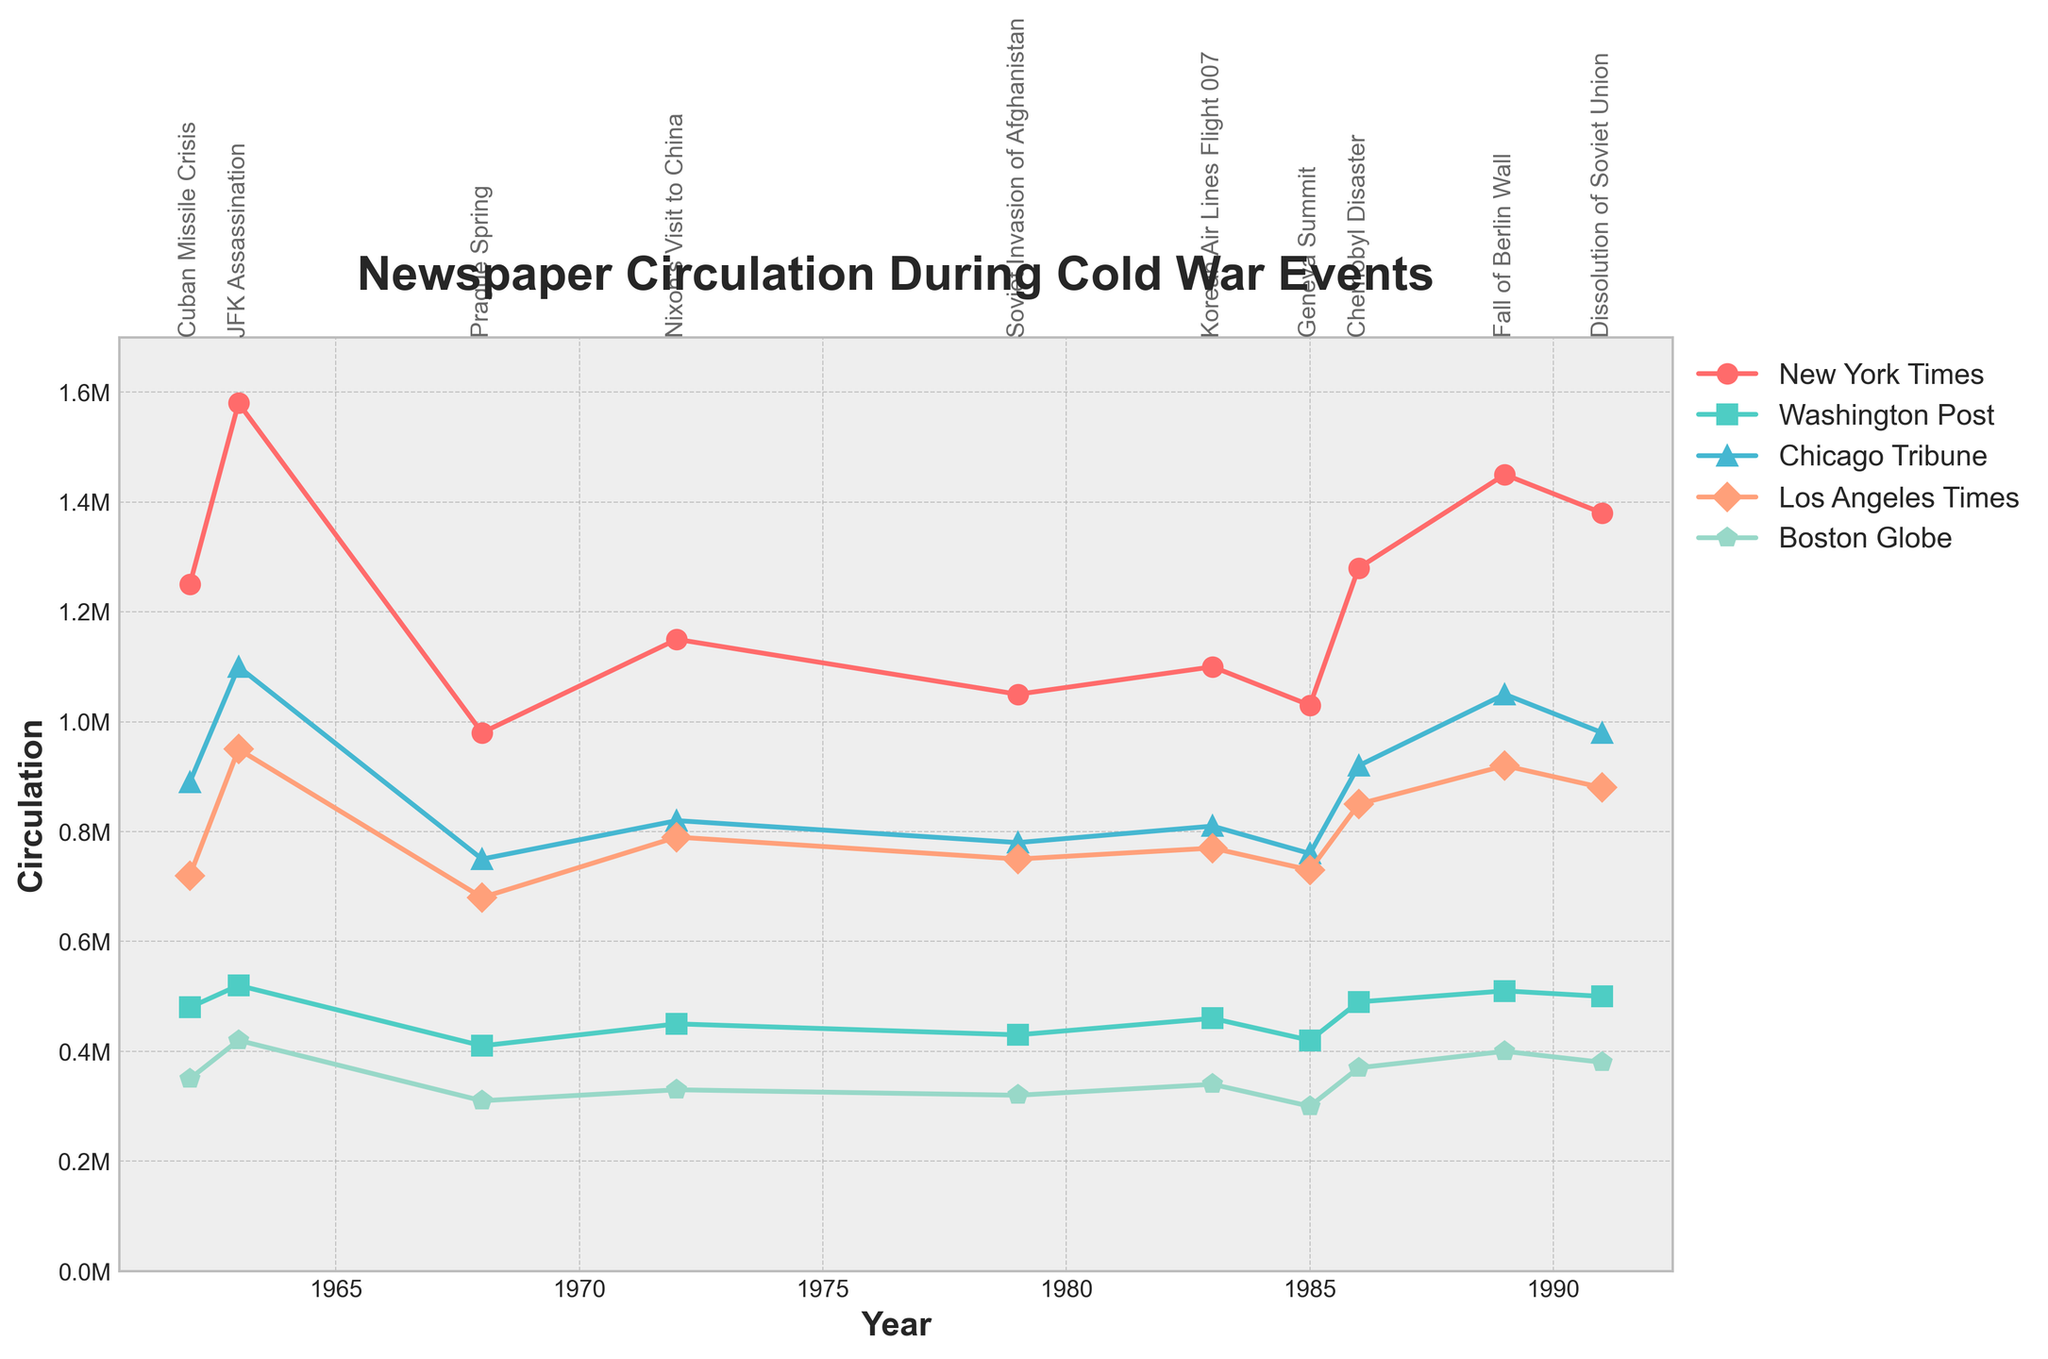Which newspaper saw the highest peak in circulation during the JFK Assassination? To find the highest peak during the JFK Assassination, observe the data point for 1963. The New York Times had the highest circulation with 1,580,000.
Answer: New York Times What event led to the lowest circulation for newspapers like the Washington Post and Boston Globe? Look at the data points for each year and identify the lowest values. For the Washington Post and Boston Globe, the Prague Spring in 1968 had the lowest circulations of 410,000 and 310,000 respectively.
Answer: Prague Spring How did the circulation of the Los Angeles Times change from the Cuban Missile Crisis to the Fall of Berlin Wall? Note the values for the Los Angeles Times in 1962 and 1989. The values increased from 720,000 to 920,000, which is a change of +200,000.
Answer: Increased by 200,000 Which event saw a higher circulation increase, the New York Times during the Chernobyl Disaster or the Chicago Tribune during the Fall of Berlin Wall compared to the previous event? For the New York Times, the increase from the previous event in 1985 (Geneva Summit) to 1986 (Chernobyl Disaster) was 1280000 - 1030000 = 250000. For the Chicago Tribune, the increase from 1986 (Chernobyl Disaster) to 1989 (Fall of Berlin Wall) was 1050000 - 920000 = 130000. The New York Times saw a higher increase.
Answer: Chernobyl Disaster (New York Times) Compare the trends in circulation for the Washington Post and Chicago Tribune between 1985 and 1991, and determine which newspaper had a more stable circulation. Examine the circulations for the listed years. The values for the Washington Post fluctuate between 420,000 and 500,000, whereas the Chicago Tribune's values range from 760,000 to 980,000. The smaller range (80,000 vs 220,000) indicates the Washington Post had a more stable circulation.
Answer: Washington Post Which newspaper had the smallest relative circulation change during the Soviet Invasion of Afghanistan (1979) compared to Nixon's Visit to China (1972)? For each newspaper, calculate the relative change as (value in 1979 - value in 1972) / value in 1972. New York Times: (1050000 - 1150000) / 1150000 = -0.087; Washington Post: (430000 - 450000) / 450000 = -0.044; Chicago Tribune: (780000 - 820000) / 820000 = -0.049; Los Angeles Times: (750000 - 790000) / 790000 = -0.051; Boston Globe: (320000 - 330000) / 330000 = -0.030. The Boston Globe had the smallest relative change.
Answer: Boston Globe 